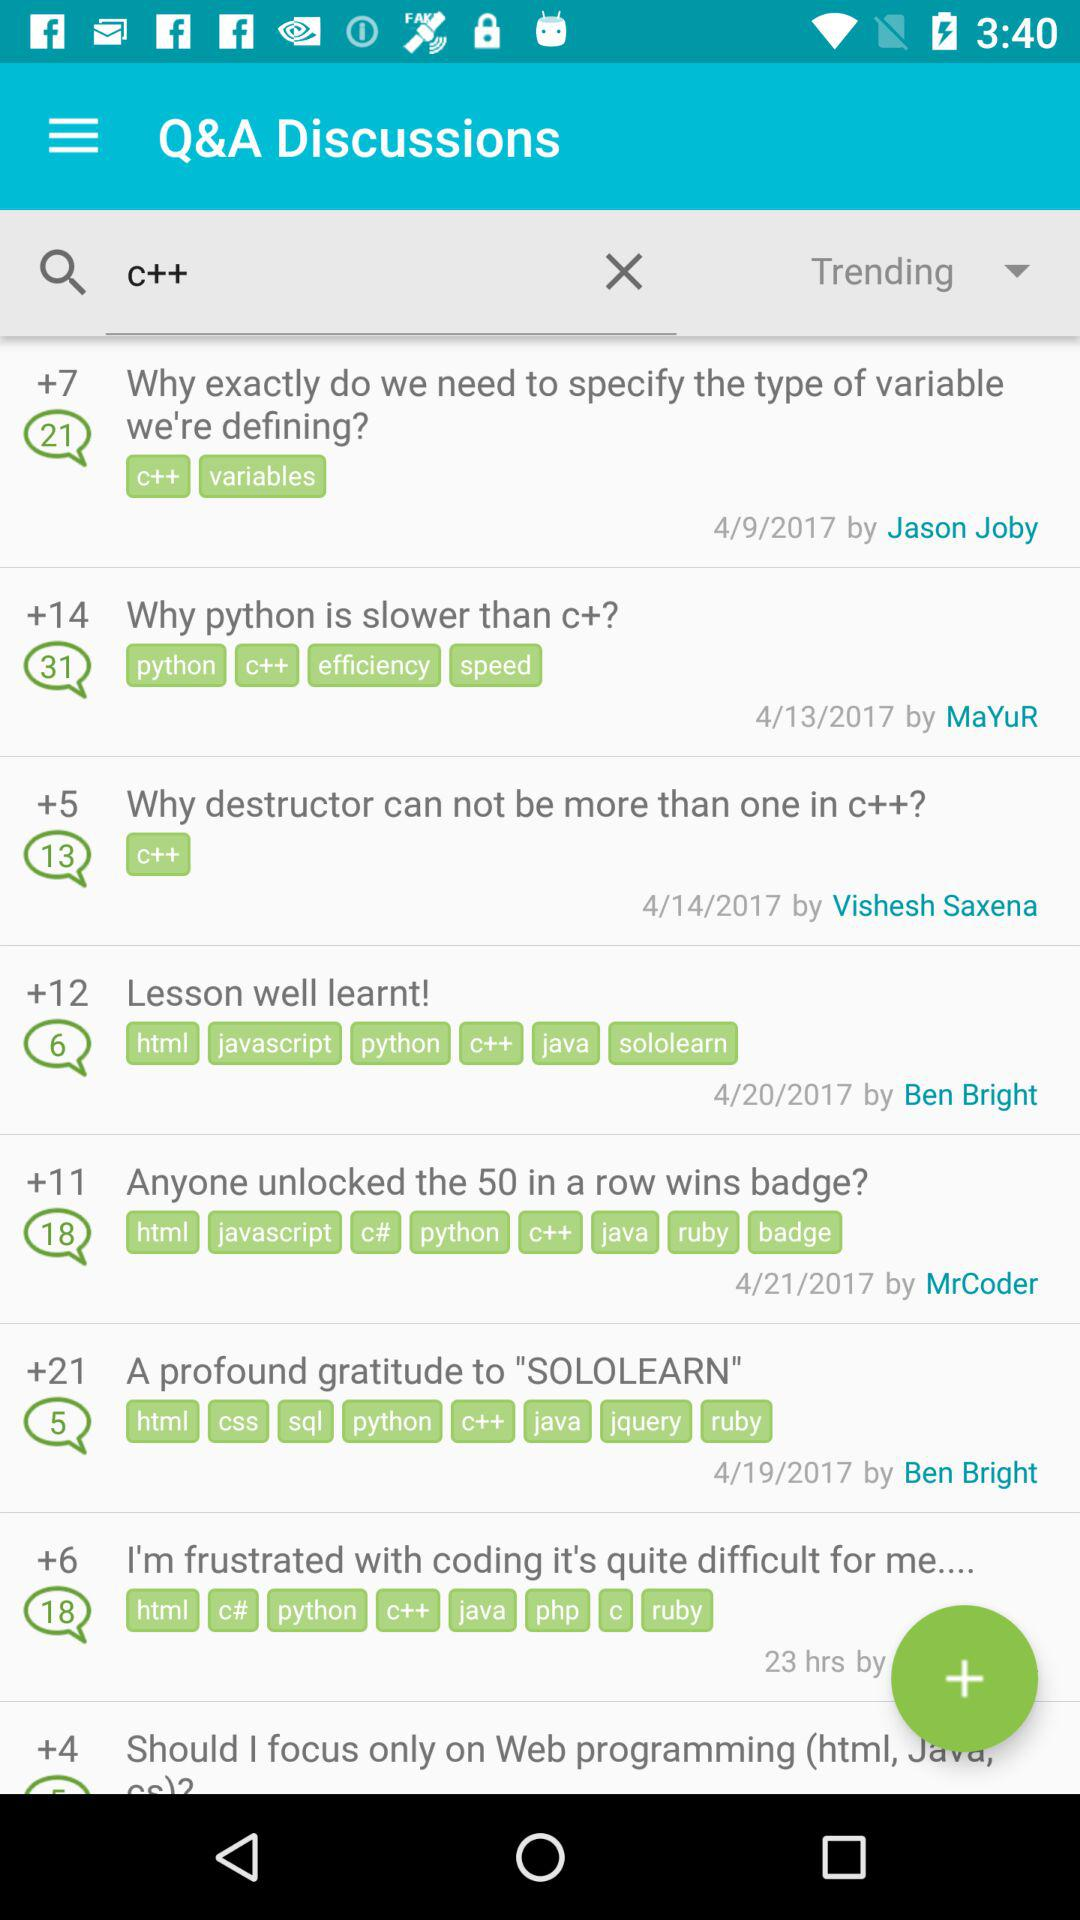On what date was the question "Why destructor can not be more than one in C++" posted? The question was posted on the date "4/14/2017". 